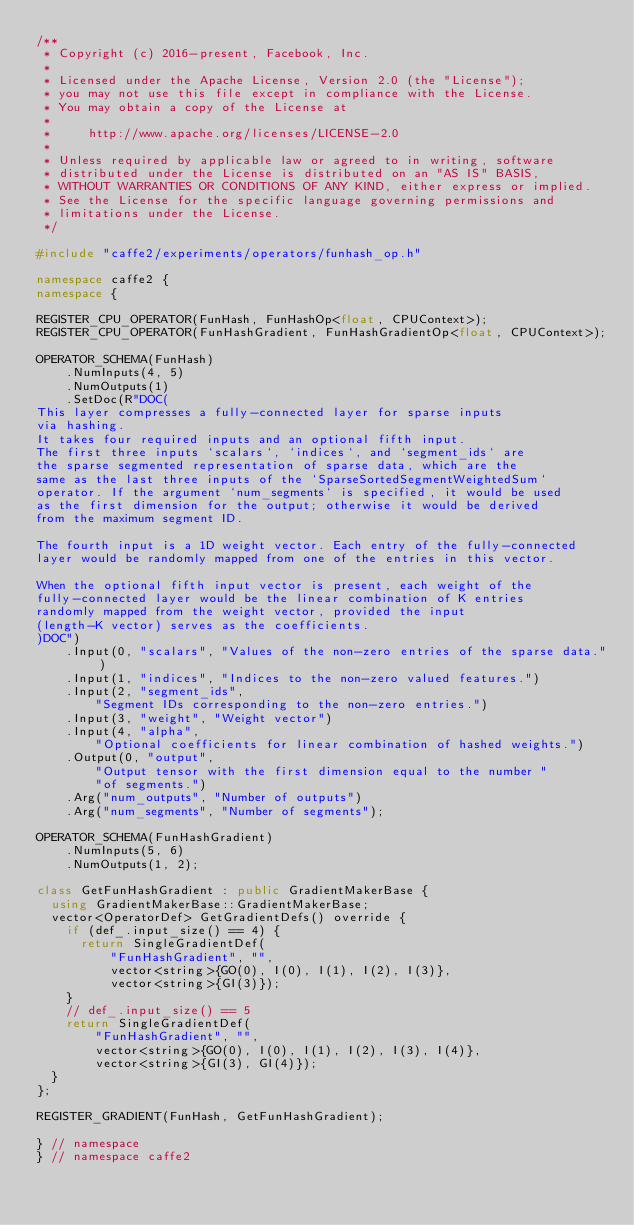<code> <loc_0><loc_0><loc_500><loc_500><_C++_>/**
 * Copyright (c) 2016-present, Facebook, Inc.
 *
 * Licensed under the Apache License, Version 2.0 (the "License");
 * you may not use this file except in compliance with the License.
 * You may obtain a copy of the License at
 *
 *     http://www.apache.org/licenses/LICENSE-2.0
 *
 * Unless required by applicable law or agreed to in writing, software
 * distributed under the License is distributed on an "AS IS" BASIS,
 * WITHOUT WARRANTIES OR CONDITIONS OF ANY KIND, either express or implied.
 * See the License for the specific language governing permissions and
 * limitations under the License.
 */

#include "caffe2/experiments/operators/funhash_op.h"

namespace caffe2 {
namespace {

REGISTER_CPU_OPERATOR(FunHash, FunHashOp<float, CPUContext>);
REGISTER_CPU_OPERATOR(FunHashGradient, FunHashGradientOp<float, CPUContext>);

OPERATOR_SCHEMA(FunHash)
    .NumInputs(4, 5)
    .NumOutputs(1)
    .SetDoc(R"DOC(
This layer compresses a fully-connected layer for sparse inputs
via hashing.
It takes four required inputs and an optional fifth input.
The first three inputs `scalars`, `indices`, and `segment_ids` are
the sparse segmented representation of sparse data, which are the
same as the last three inputs of the `SparseSortedSegmentWeightedSum`
operator. If the argument `num_segments` is specified, it would be used
as the first dimension for the output; otherwise it would be derived
from the maximum segment ID.

The fourth input is a 1D weight vector. Each entry of the fully-connected
layer would be randomly mapped from one of the entries in this vector.

When the optional fifth input vector is present, each weight of the
fully-connected layer would be the linear combination of K entries
randomly mapped from the weight vector, provided the input
(length-K vector) serves as the coefficients.
)DOC")
    .Input(0, "scalars", "Values of the non-zero entries of the sparse data.")
    .Input(1, "indices", "Indices to the non-zero valued features.")
    .Input(2, "segment_ids",
        "Segment IDs corresponding to the non-zero entries.")
    .Input(3, "weight", "Weight vector")
    .Input(4, "alpha",
        "Optional coefficients for linear combination of hashed weights.")
    .Output(0, "output",
        "Output tensor with the first dimension equal to the number "
        "of segments.")
    .Arg("num_outputs", "Number of outputs")
    .Arg("num_segments", "Number of segments");

OPERATOR_SCHEMA(FunHashGradient)
    .NumInputs(5, 6)
    .NumOutputs(1, 2);

class GetFunHashGradient : public GradientMakerBase {
  using GradientMakerBase::GradientMakerBase;
  vector<OperatorDef> GetGradientDefs() override {
    if (def_.input_size() == 4) {
      return SingleGradientDef(
          "FunHashGradient", "",
          vector<string>{GO(0), I(0), I(1), I(2), I(3)},
          vector<string>{GI(3)});
    }
    // def_.input_size() == 5
    return SingleGradientDef(
        "FunHashGradient", "",
        vector<string>{GO(0), I(0), I(1), I(2), I(3), I(4)},
        vector<string>{GI(3), GI(4)});
  }
};

REGISTER_GRADIENT(FunHash, GetFunHashGradient);

} // namespace
} // namespace caffe2
</code> 